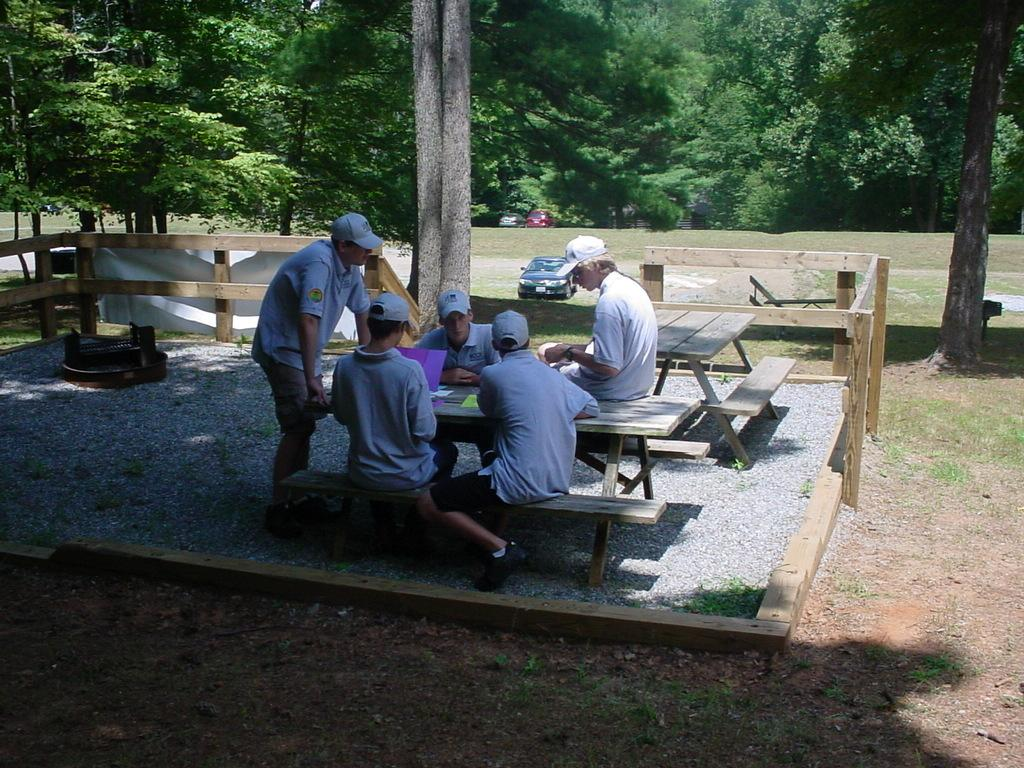How many people are in the image? There are five persons in the image. What are the majority of the persons doing in the image? Four of the persons are sitting on a bench. What is the remaining person doing in the image? One person is standing and talking. What can be seen in the background of the image? There are many trees near the persons. What else is present near the persons in the image? Cars are present near the persons. What type of scent can be smelled coming from the river in the image? There is no river present in the image, so it is not possible to determine what scent might be smelled. 